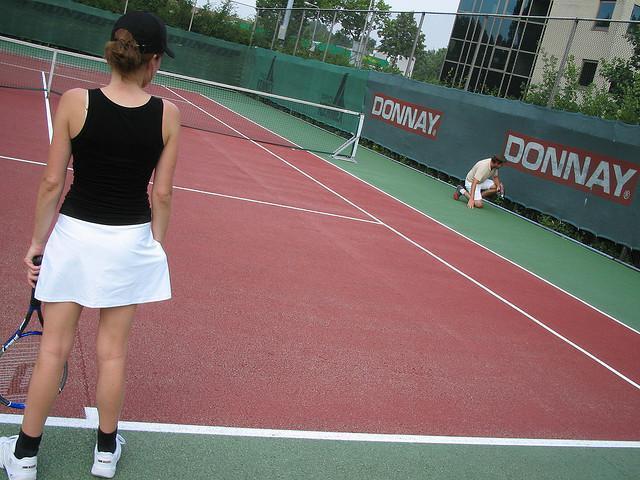How many people are in this picture?
Give a very brief answer. 2. 